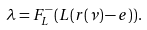<formula> <loc_0><loc_0><loc_500><loc_500>\lambda = F ^ { - } _ { L } ( L ( r ( \nu ) - e ) ) .</formula> 